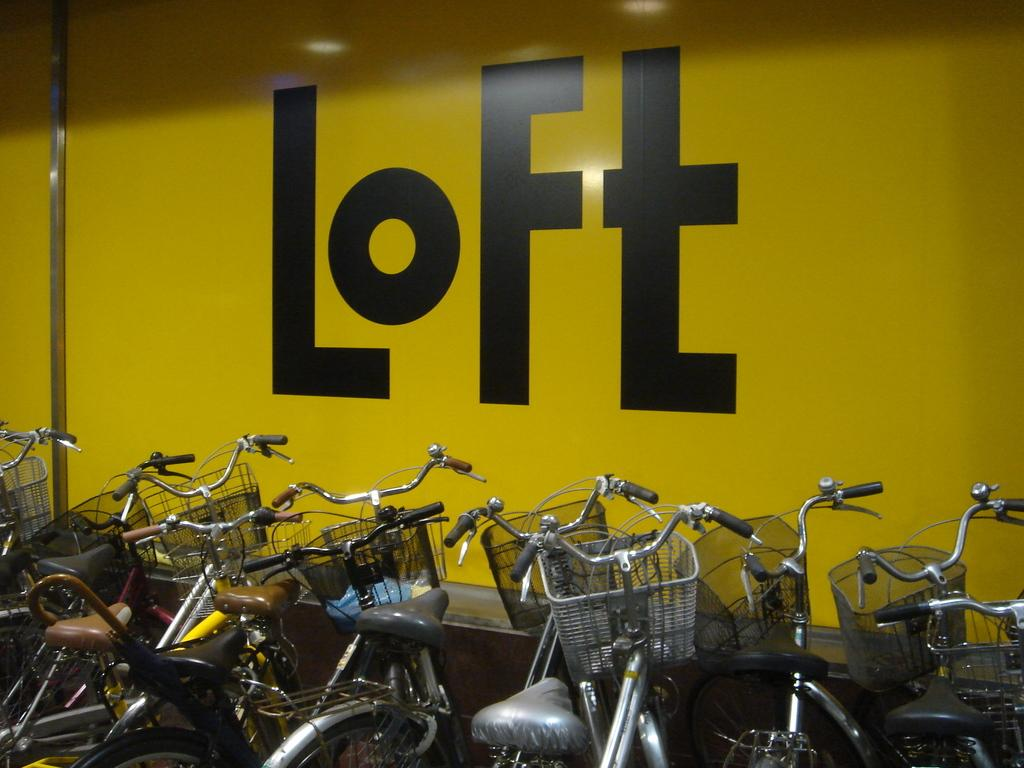What type of vehicles are present in the image? There are bicycles in the image. Can you describe any other features in the image besides the bicycles? Yes, there is a wall with text on it in the image. What type of fruit is hanging from the bicycles in the image? There is no fruit hanging from the bicycles in the image. Can you tell me how many uncles are depicted in the image? There are no people, including uncles, depicted in the image; it only features bicycles and a wall with text. 